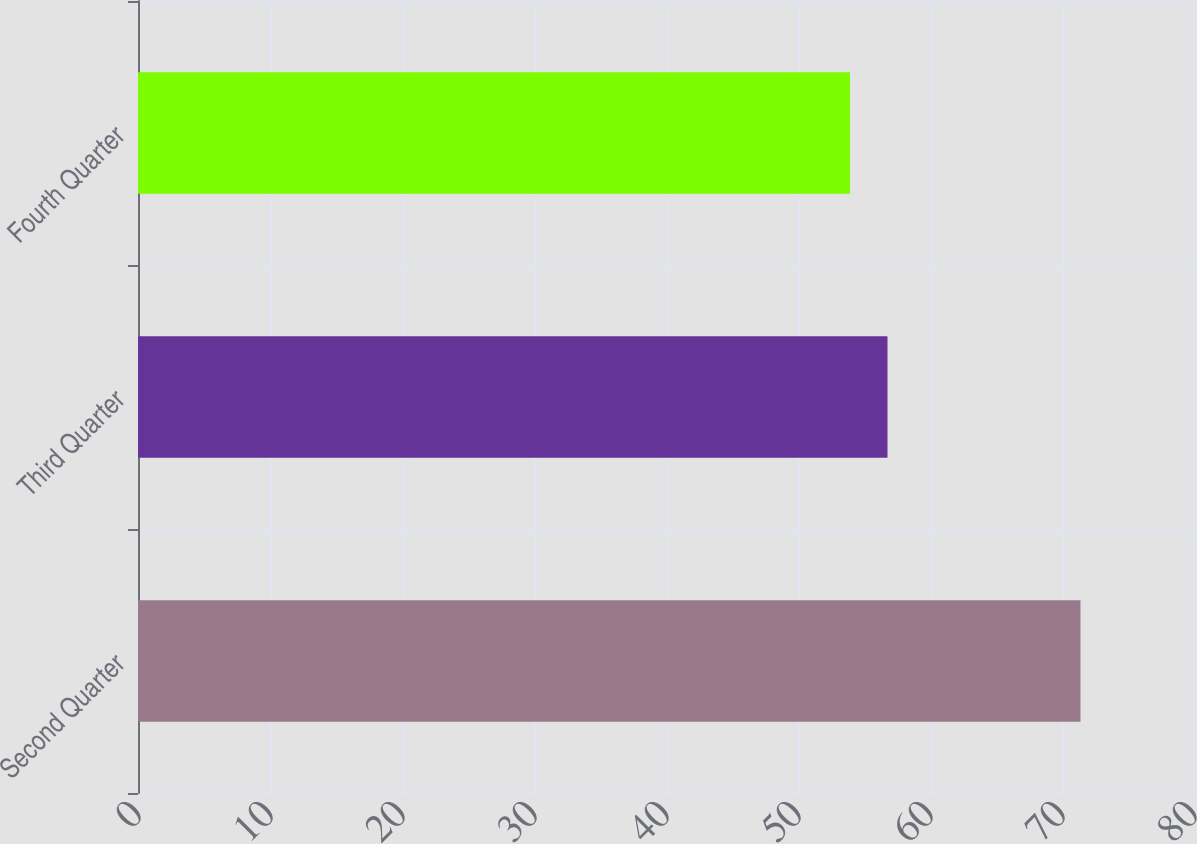Convert chart to OTSL. <chart><loc_0><loc_0><loc_500><loc_500><bar_chart><fcel>Second Quarter<fcel>Third Quarter<fcel>Fourth Quarter<nl><fcel>71.4<fcel>56.78<fcel>53.94<nl></chart> 